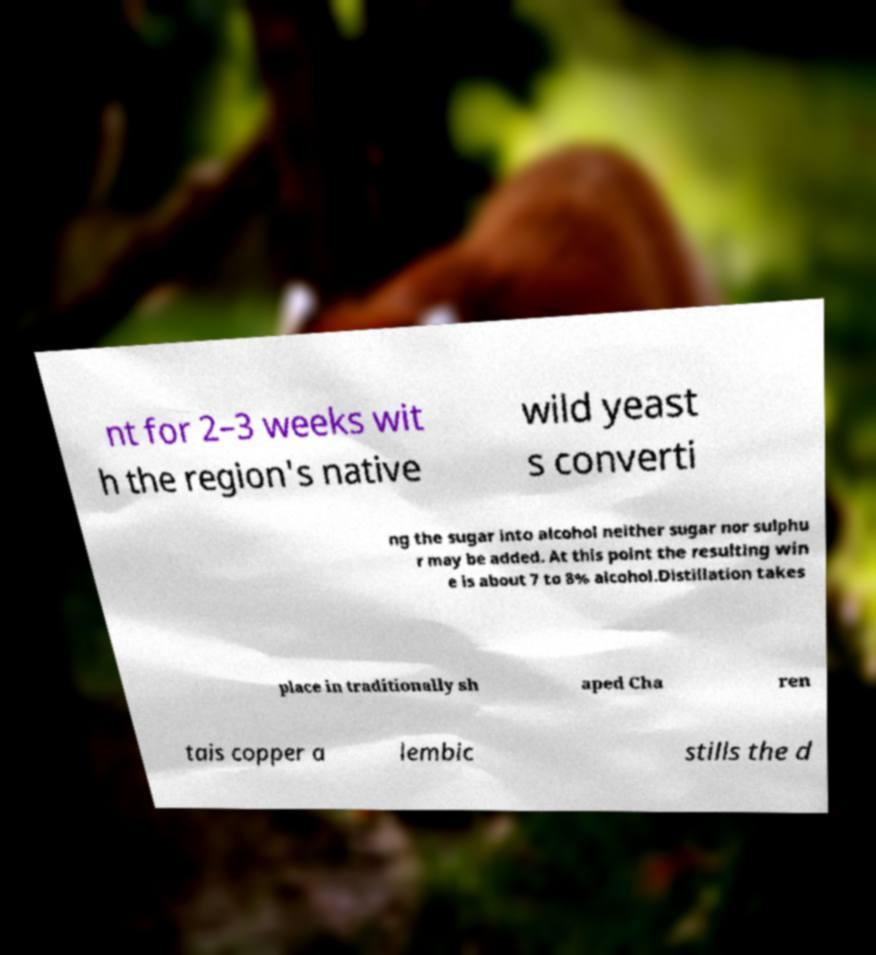Can you accurately transcribe the text from the provided image for me? nt for 2–3 weeks wit h the region's native wild yeast s converti ng the sugar into alcohol neither sugar nor sulphu r may be added. At this point the resulting win e is about 7 to 8% alcohol.Distillation takes place in traditionally sh aped Cha ren tais copper a lembic stills the d 